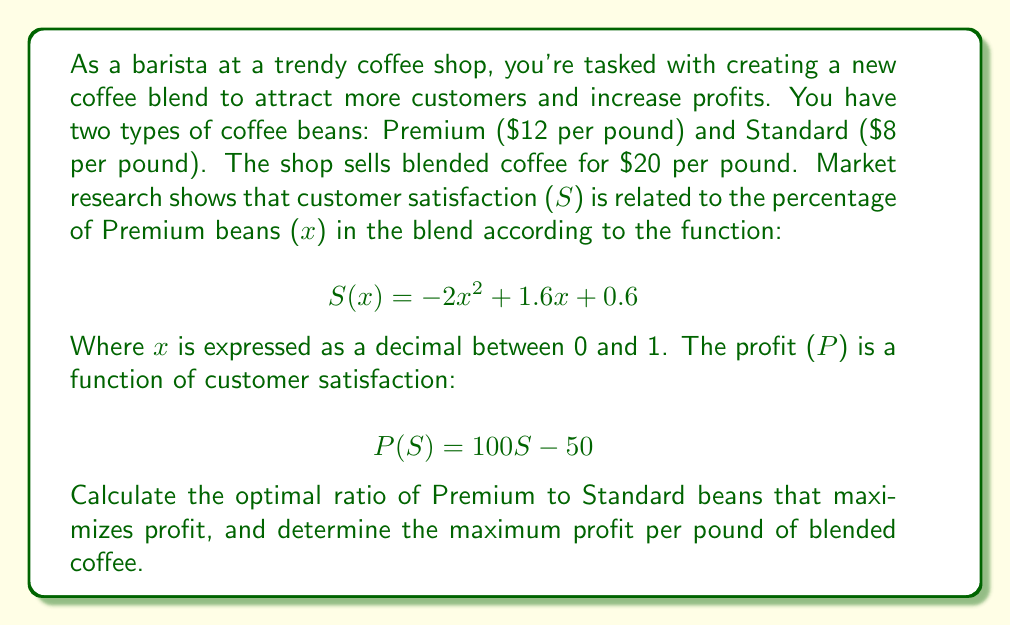Can you solve this math problem? Let's approach this step-by-step:

1) First, we need to express profit as a function of x:
   $P(x) = P(S(x)) = 100S(x) - 50$
   $P(x) = 100(-2x^2 + 1.6x + 0.6) - 50$
   $P(x) = -200x^2 + 160x + 10$

2) To find the maximum profit, we need to find the value of x where the derivative of P(x) is zero:
   $\frac{dP}{dx} = -400x + 160$
   Set this equal to zero:
   $-400x + 160 = 0$
   $-400x = -160$
   $x = 0.4$

3) To confirm this is a maximum, we can check the second derivative:
   $\frac{d^2P}{dx^2} = -400$, which is negative, confirming a maximum.

4) So, the optimal blend is 40% Premium beans and 60% Standard beans.

5) To calculate the maximum profit per pound:
   $P(0.4) = -200(0.4)^2 + 160(0.4) + 10$
   $= -32 + 64 + 10 = 42$

6) However, we need to subtract the cost of the beans:
   Cost per pound = $0.4 * 12 + 0.6 * 8 = $4.80 + $4.80 = $9.60$
   
   Actual profit per pound = $42 + $9.60 = $32.40$

Therefore, the maximum profit per pound is $32.40 when using a blend of 40% Premium beans and 60% Standard beans.
Answer: The optimal ratio is 40% Premium beans to 60% Standard beans, yielding a maximum profit of $32.40 per pound of blended coffee. 